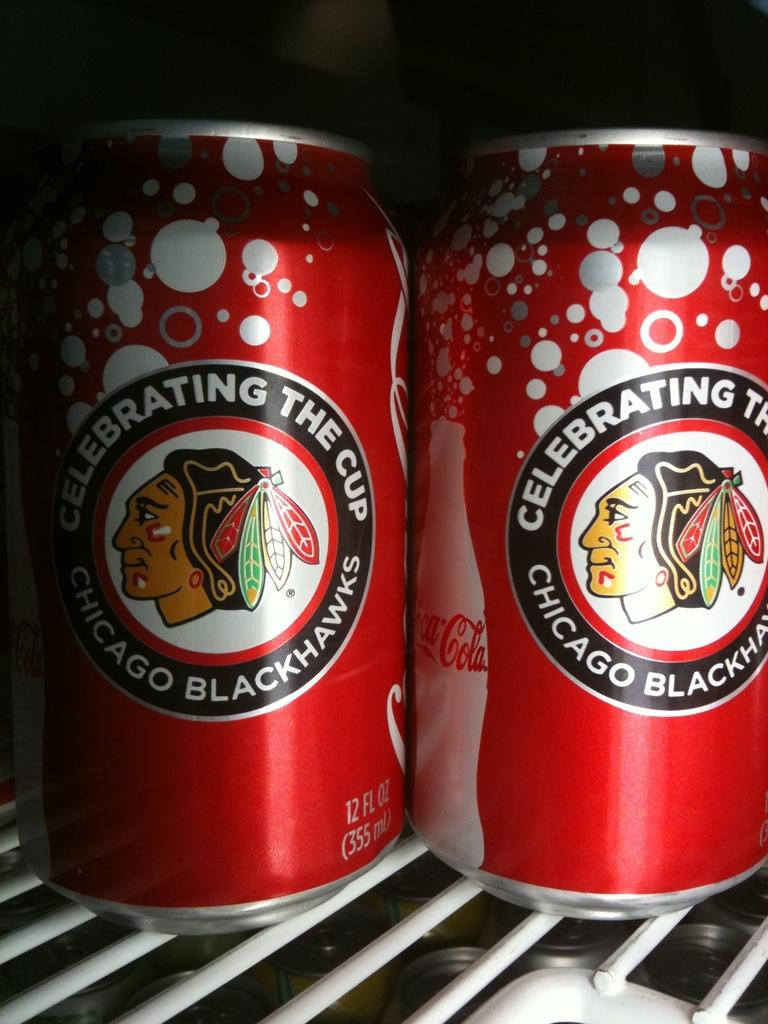What type of objects are present in the image? There are tins in the image. What distinguishes the tins from each other? The tins have a logo on them and text printed on them. Can you describe the color of the object in the image? There is a white-colored object in the image. What type of fruit can be seen growing on the trees in the image? There are no trees or fruit present in the image; it features tins with a logo and text printed on them, as well as a white-colored object. Can you tell me how many screws are visible in the image? There are no screws visible in the image. 